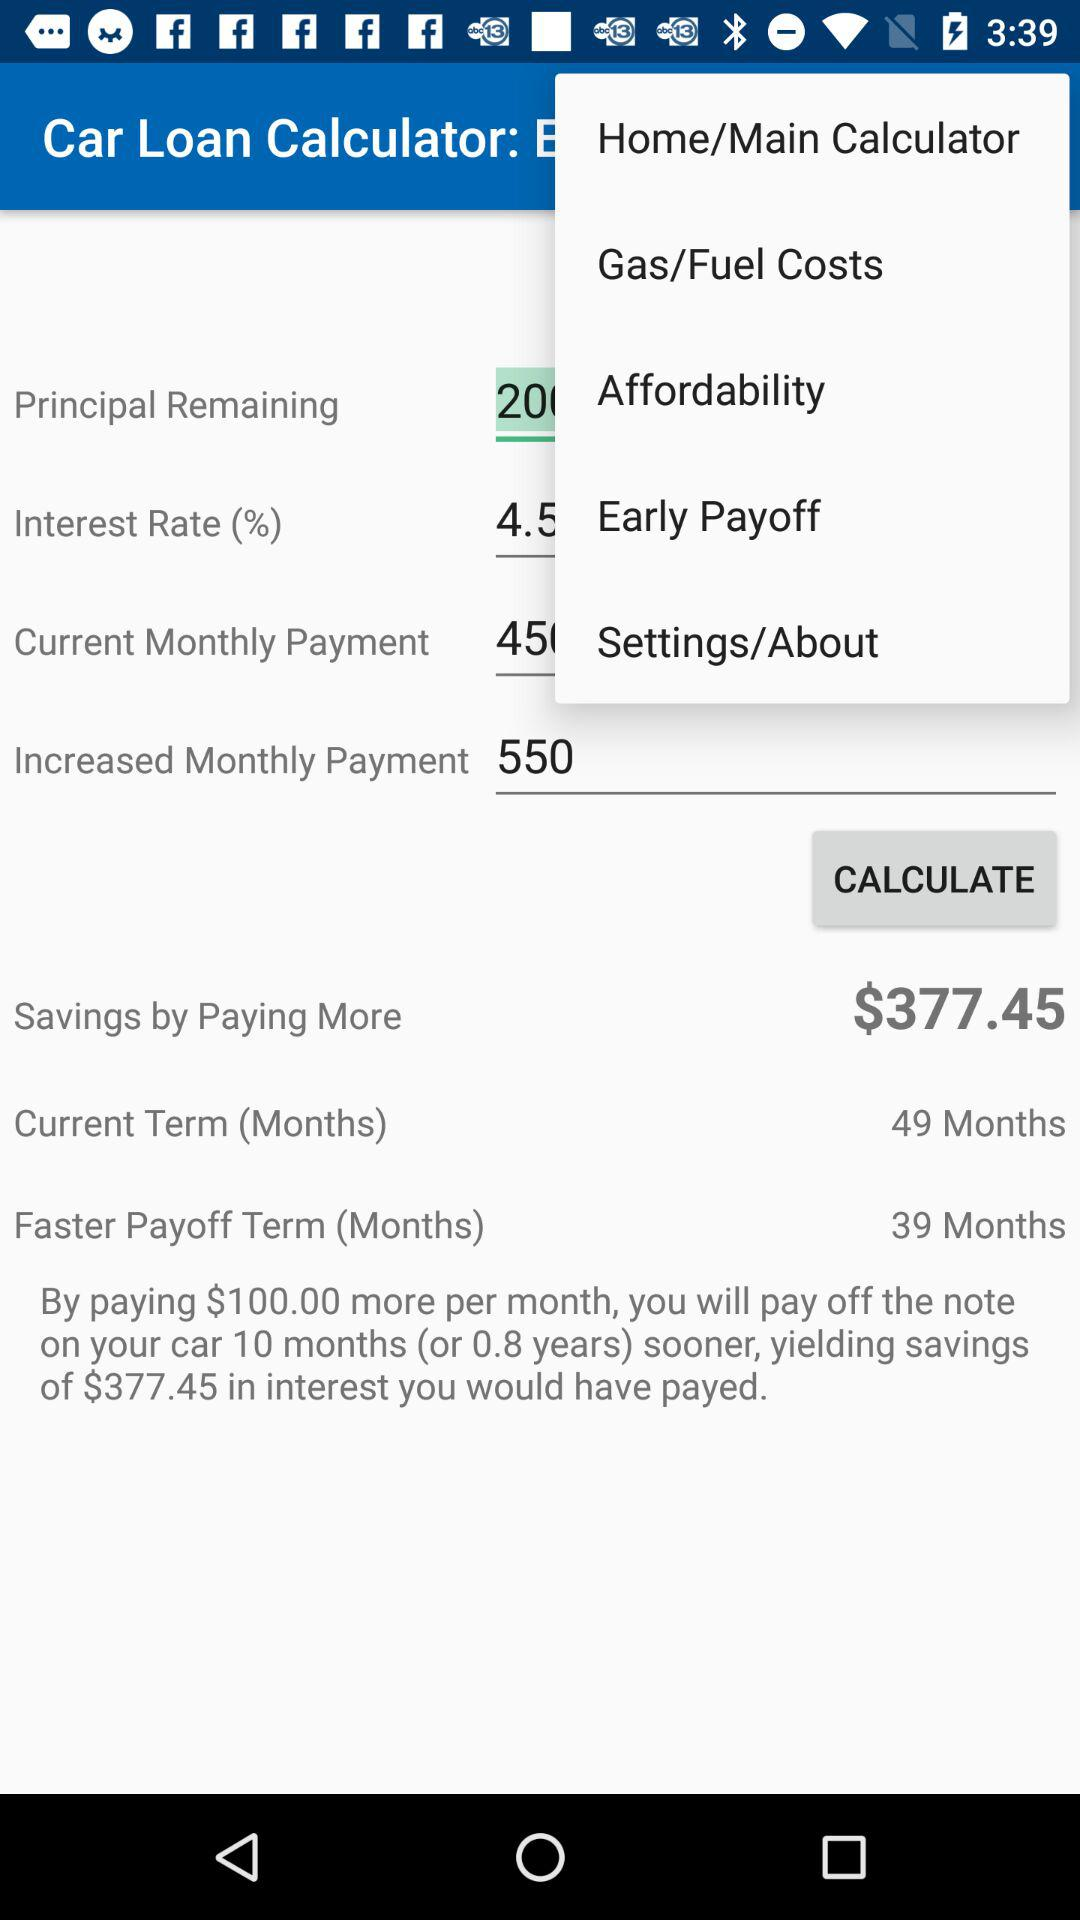What is the calculated amount?
When the provided information is insufficient, respond with <no answer>. <no answer> 